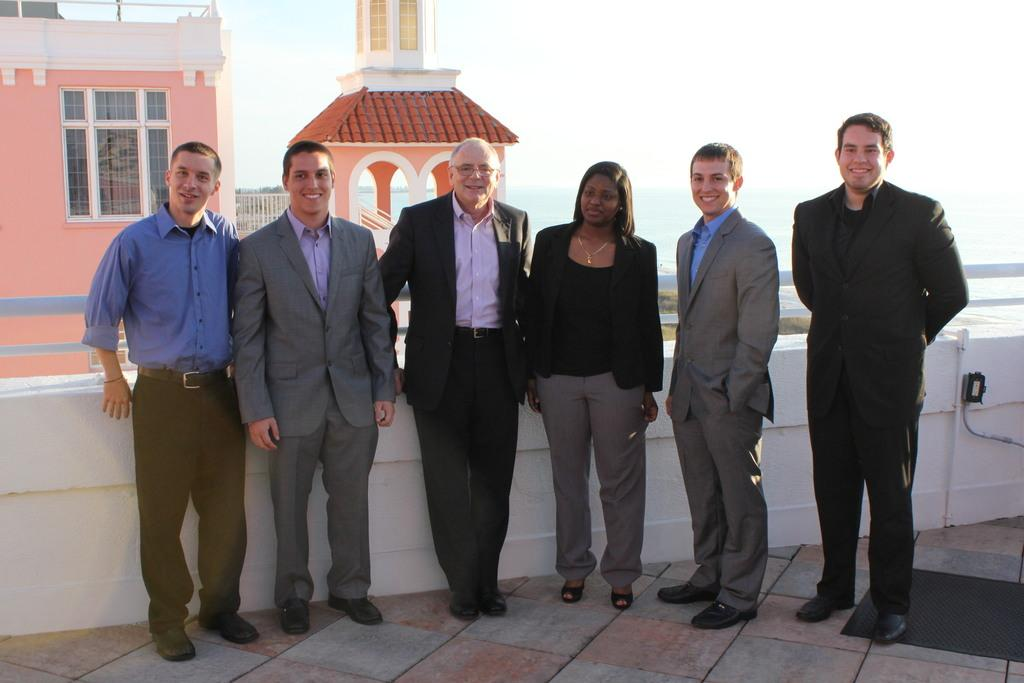What are the people in the image doing? The people in the image are standing and smiling. What is the surface beneath the people's feet in the image? There is a floor visible in the image. What is the background of the image composed of? In the background of the image, there are windows, walls, pillars, water, and sky visible. How many children are sitting on the scale in the image? There is no scale or children present in the image. Is there a birthday cake visible in the image? There is no birthday cake or reference to a birthday in the image. 